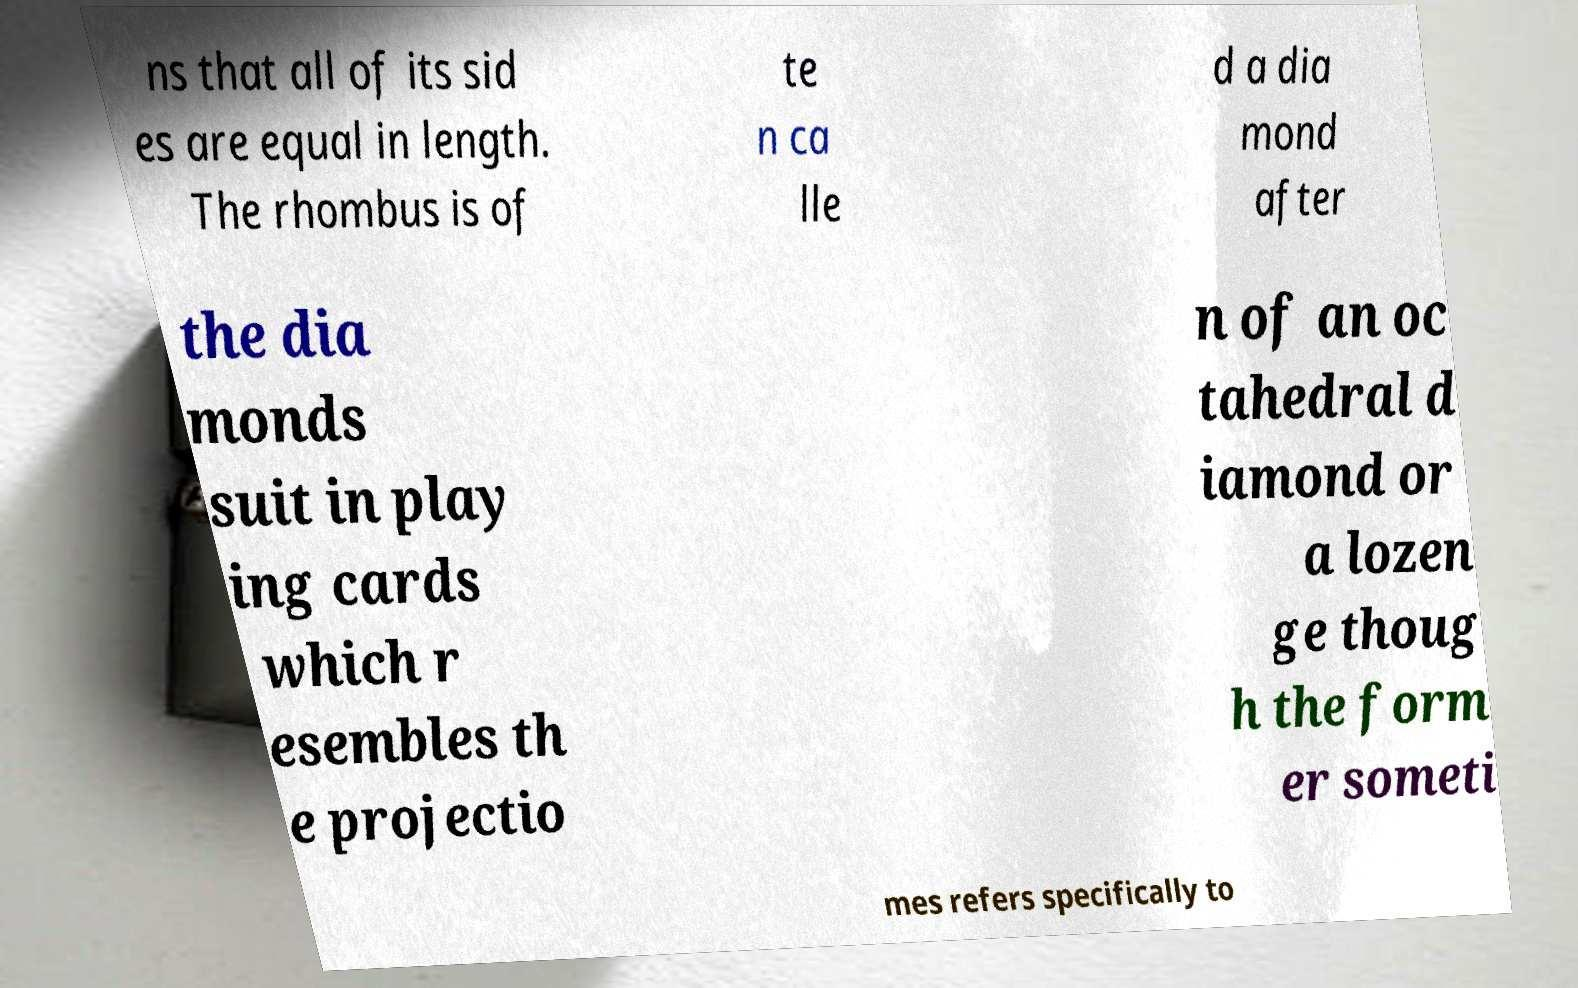Can you accurately transcribe the text from the provided image for me? ns that all of its sid es are equal in length. The rhombus is of te n ca lle d a dia mond after the dia monds suit in play ing cards which r esembles th e projectio n of an oc tahedral d iamond or a lozen ge thoug h the form er someti mes refers specifically to 